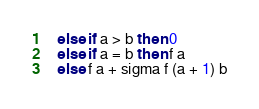<code> <loc_0><loc_0><loc_500><loc_500><_OCaml_>  else if a > b then 0
  else if a = b then f a
  else f a + sigma f (a + 1) b
</code> 